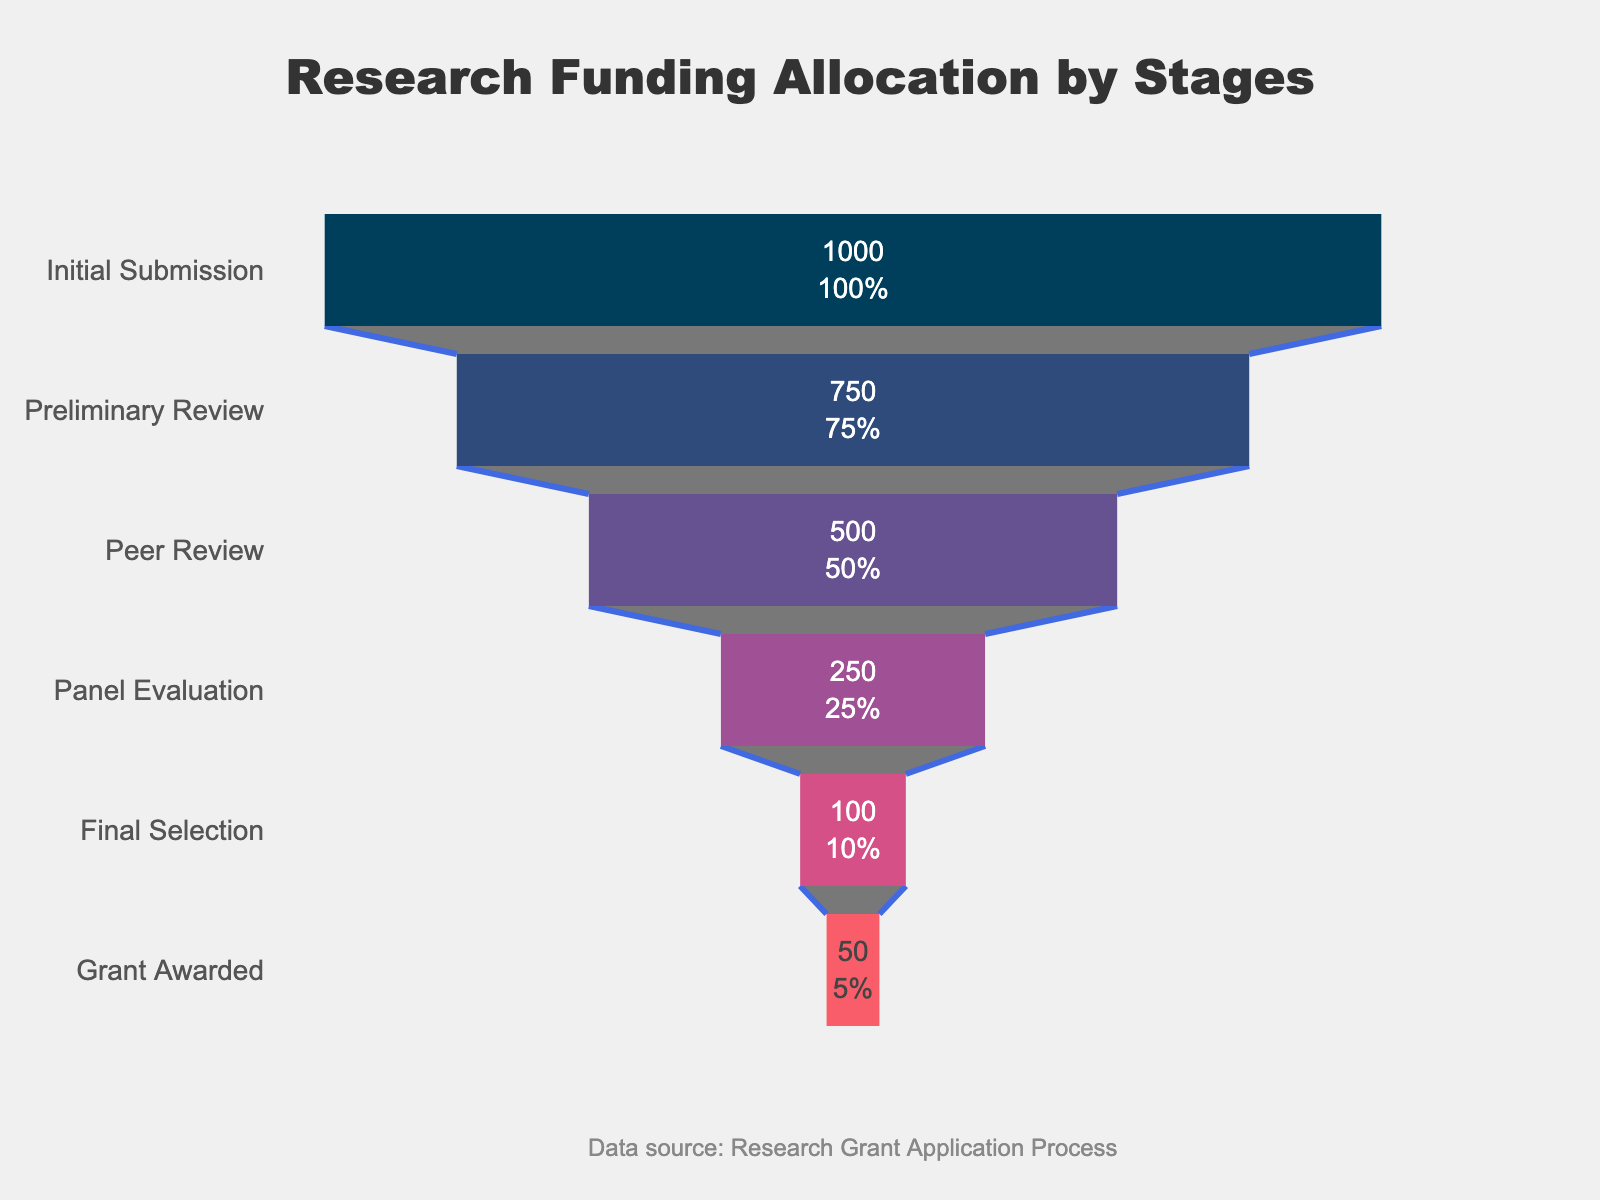What is the title of the funnel chart? The title of the funnel chart is displayed prominently at the top and reads "Research Funding Allocation by Stages".
Answer: Research Funding Allocation by Stages How many stages are displayed in the funnel chart? Count the different stages listed on the y-axis of the funnel chart, which includes "Initial Submission", "Preliminary Review", "Peer Review", "Panel Evaluation", "Final Selection", and "Grant Awarded".
Answer: 6 What is the color of the stage with the fewest applicants? Look at the color code of the segment for "Grant Awarded", which has the fewest applicants at 50.
Answer: Red How many applicants were reduced from Peer Review to Panel Evaluation? Subtract the number of applicants in "Panel Evaluation" from the number of applicants in "Peer Review" (500 - 250).
Answer: 250 What percentage of initial applicants made it to the Preliminary Review? Calculate the percentage by taking the number in "Preliminary Review" divided by "Initial Submission" and multiply by 100 ((750 / 1000) * 100).
Answer: 75% Which stage experienced the largest drop in the number of applicants? Compare the differences in the number of applicants between each consecutive stage and identify the largest drop, which is from "Peer Review" (500) to "Panel Evaluation" (250).
Answer: Peer Review to Panel Evaluation What is the smallest percentage stage mentioned on the chart? Look at the percentage values inside the funnel chart segments and find that "Grant Awarded" has the smallest percentage.
Answer: 5% Calculate the retention rate from Final Selection to Grant Awarded. Divide the number of applicants who were awarded grants by those in Final Selection and multiply by 100 ((50 / 100) * 100).
Answer: 50% Which stage retained exactly half of the applicants compared to the previous stage? Assess the stages where the number of applicants is approximately half of the previous stage, which is from "Final Selection" (100) to "Grant Awarded" (50).
Answer: Final Selection to Grant Awarded How many applicants were not granted funding after reaching the Final Selection stage? Subtract the number of "Grant Awarded" from "Final Selection" applicants (100 - 50).
Answer: 50 